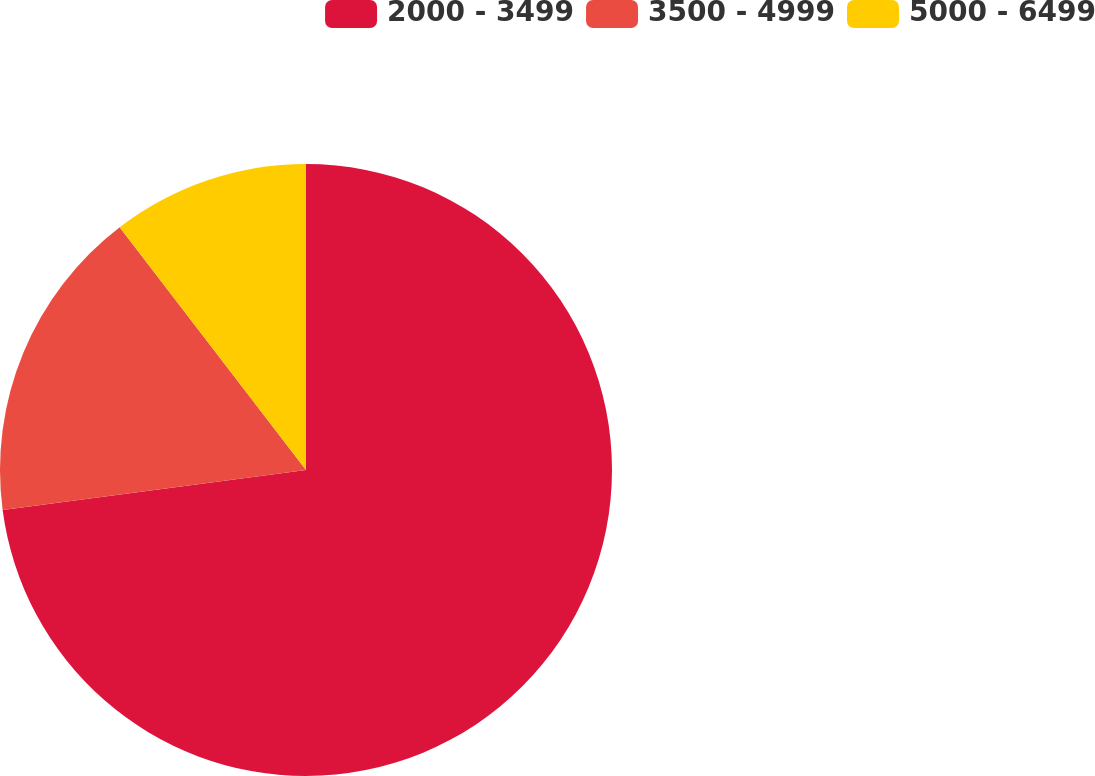Convert chart to OTSL. <chart><loc_0><loc_0><loc_500><loc_500><pie_chart><fcel>2000 - 3499<fcel>3500 - 4999<fcel>5000 - 6499<nl><fcel>72.91%<fcel>16.67%<fcel>10.42%<nl></chart> 